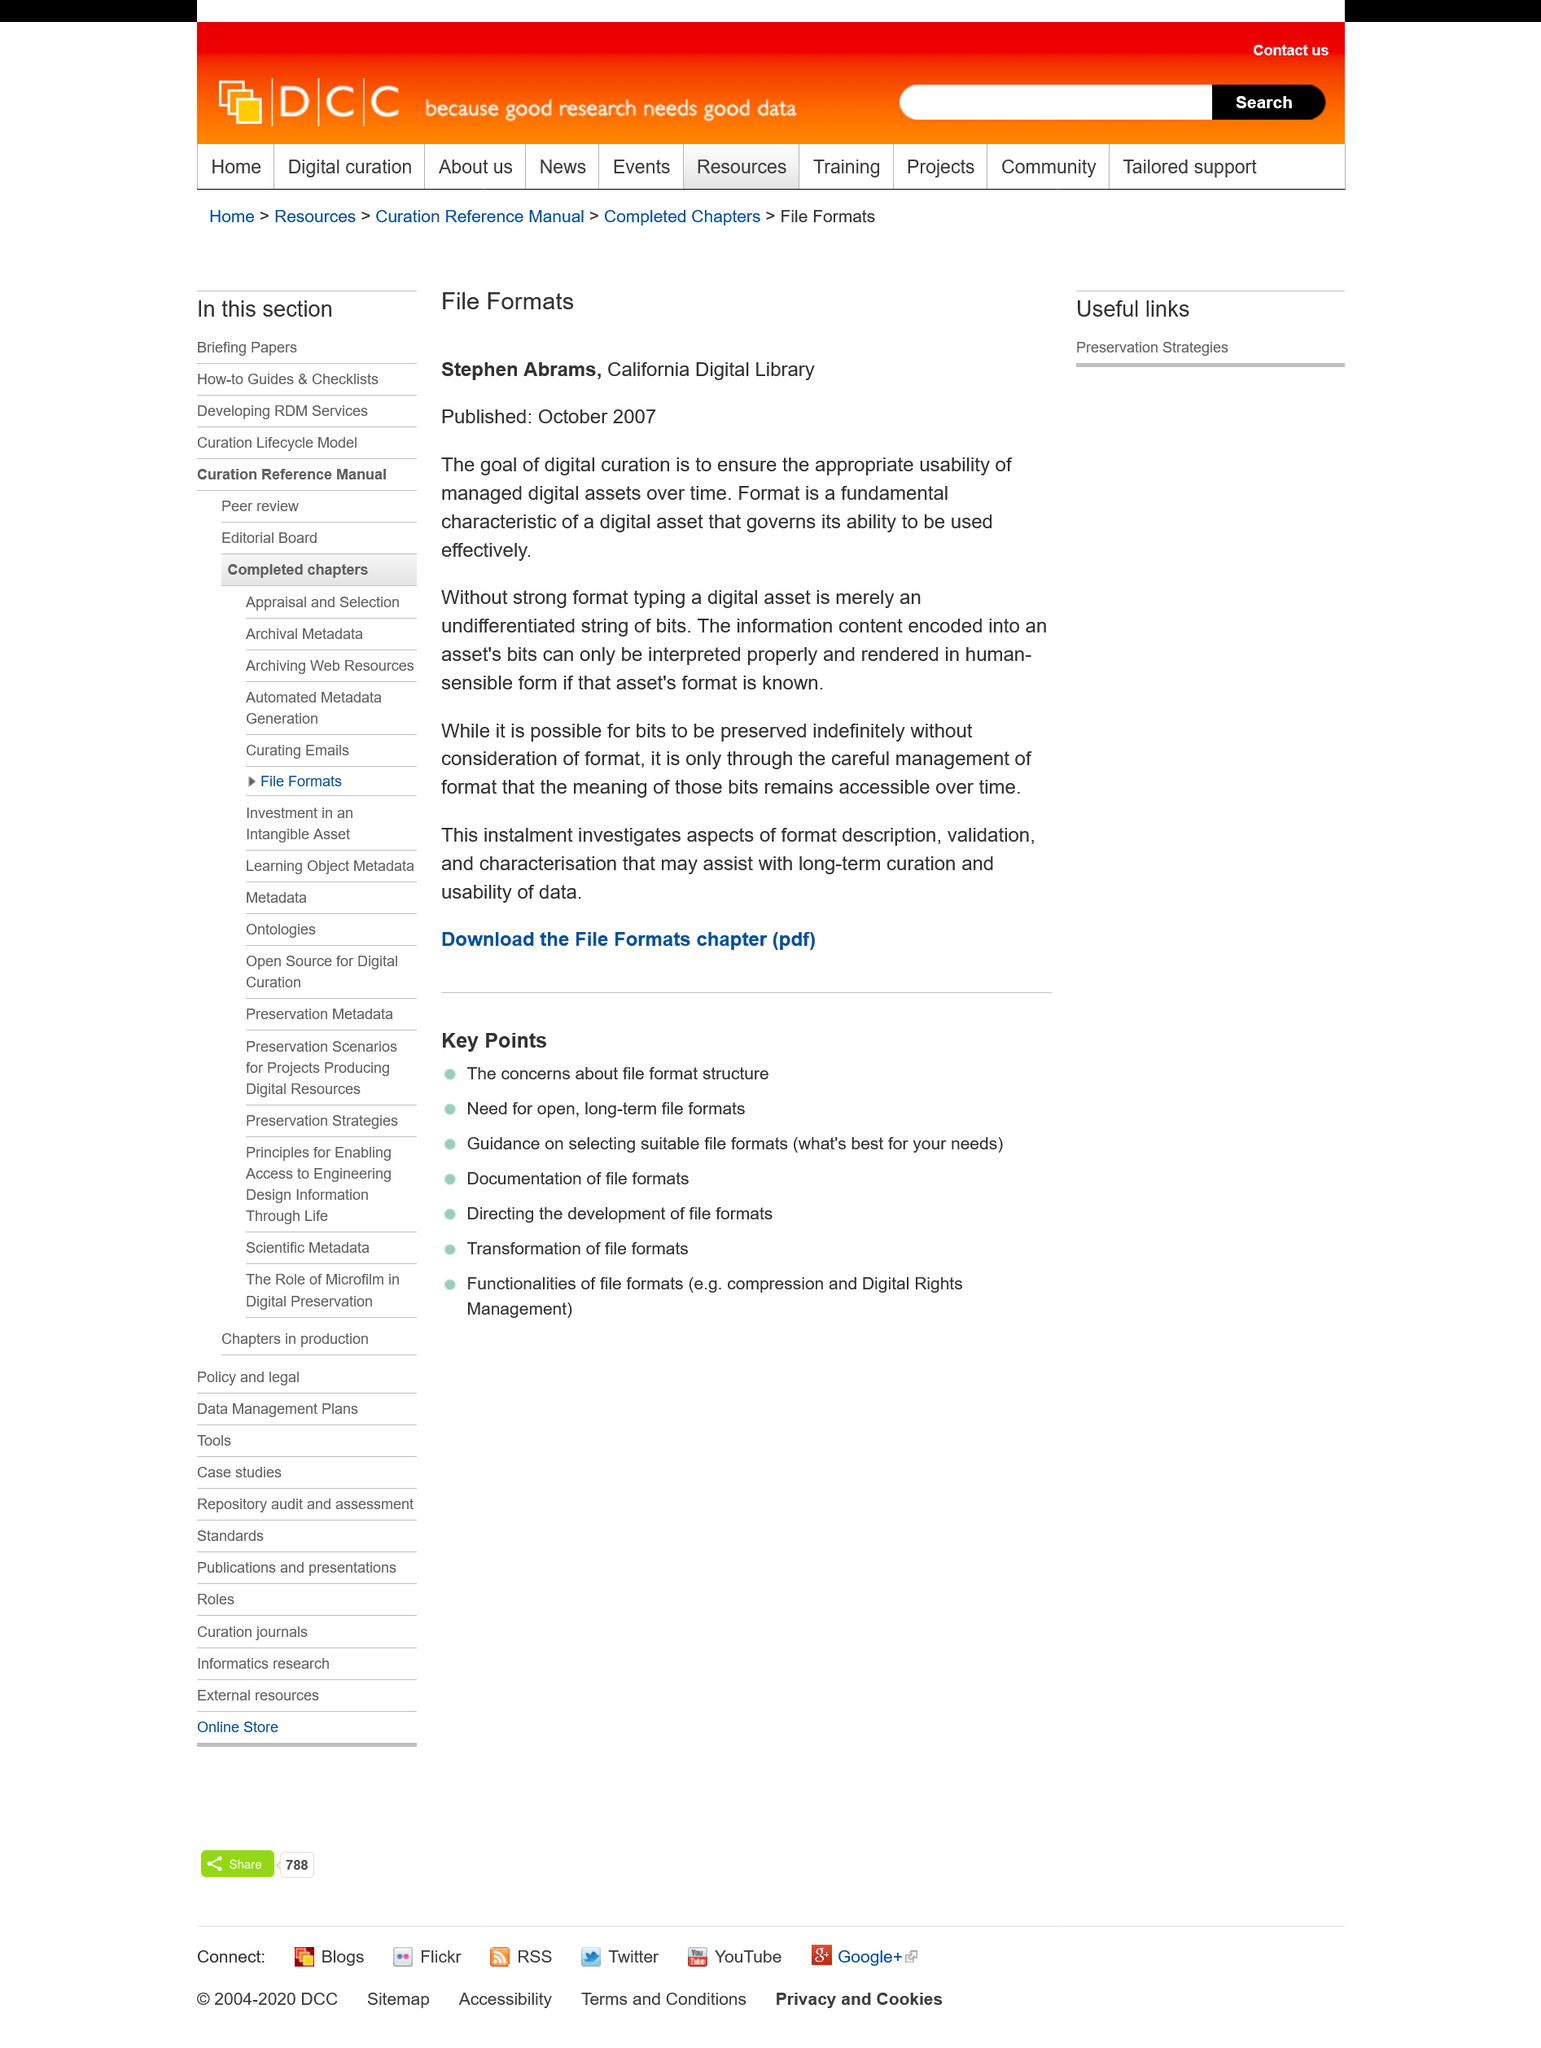Draw attention to some important aspects in this diagram. The goal of digital curation is to preserve the usability of managed digital assets for future generations. Stephen Abrams has attached his work to the organization known as the California Digital Library. Stephen Abram's article on file formats was published in October 2007. 